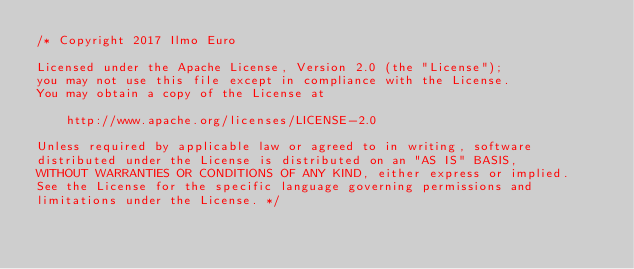Convert code to text. <code><loc_0><loc_0><loc_500><loc_500><_Ceylon_>/* Copyright 2017 Ilmo Euro

Licensed under the Apache License, Version 2.0 (the "License");
you may not use this file except in compliance with the License.
You may obtain a copy of the License at

    http://www.apache.org/licenses/LICENSE-2.0

Unless required by applicable law or agreed to in writing, software
distributed under the License is distributed on an "AS IS" BASIS,
WITHOUT WARRANTIES OR CONDITIONS OF ANY KIND, either express or implied.
See the License for the specific language governing permissions and
limitations under the License. */

</code> 